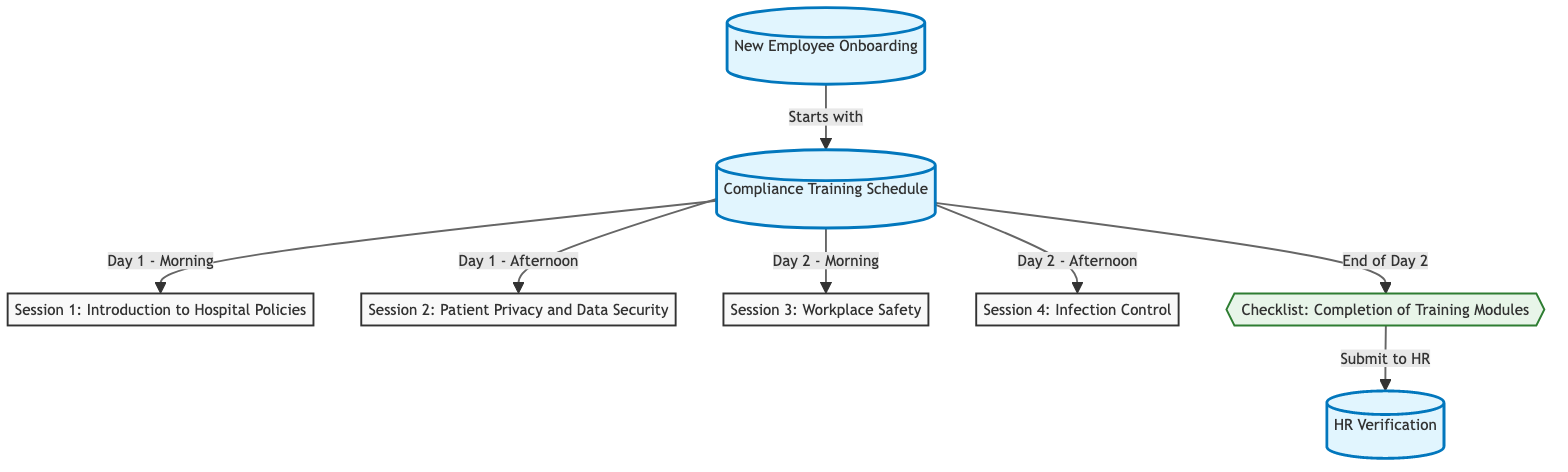What is the first session scheduled on Day 1? The diagram shows that the first session is "Session 1: Introduction to Hospital Policies," which is set for the morning of Day 1.
Answer: Session 1: Introduction to Hospital Policies How many sessions are there in total? By counting the nodes representing sessions (from Session 1 to Session 4), there are four training sessions listed in the diagram.
Answer: 4 What is the last event occurring on Day 2? According to the diagram, the last event on Day 2 is "Checklist: Completion of Training Modules."
Answer: Checklist: Completion of Training Modules Which session is scheduled for the afternoon of Day 2? The diagram indicates that "Session 4: Infection Control" takes place in the afternoon of Day 2.
Answer: Session 4: Infection Control What should be submitted to HR at the end of the training period? The diagram specifies that the "Checklist: Completion of Training Modules" should be submitted to HR after it is completed.
Answer: Checklist: Completion of Training Modules Which two sessions are scheduled before the HR verification? The sessions "Session 1: Introduction to Hospital Policies" and "Session 2: Patient Privacy and Data Security" both occur prior to the HR verification step.
Answer: Session 1: Introduction to Hospital Policies; Session 2: Patient Privacy and Data Security What connects the checklist to HR verification? The diagram shows that the checklist is submitted to HR, indicating a direct link between the completion of the checklist and the HR verification stage.
Answer: Submit to HR Is there a specific timeline given for when the compliance training starts? The diagram clearly states that the compliance training starts on Day 1, making it the specified timeline for the beginning of the training.
Answer: Day 1 What does the "highlight" class signify in this diagram? The "highlight" class is applied to key nodes to distinguish important sections like 'New Employee Onboarding,' 'Compliance Training Schedule,' and 'HR Verification.'
Answer: Important sections 